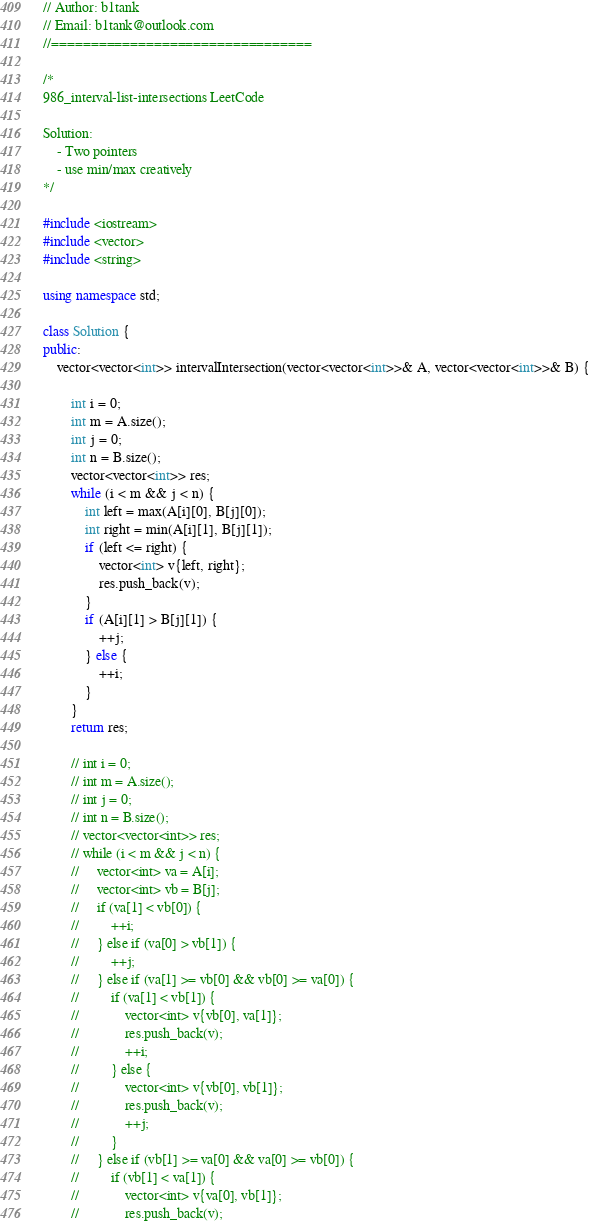<code> <loc_0><loc_0><loc_500><loc_500><_C++_>// Author: b1tank
// Email: b1tank@outlook.com
//=================================

/*
986_interval-list-intersections LeetCode

Solution: 
    - Two pointers
    - use min/max creatively
*/

#include <iostream>
#include <vector>
#include <string>

using namespace std;

class Solution {
public:
    vector<vector<int>> intervalIntersection(vector<vector<int>>& A, vector<vector<int>>& B) {
        
        int i = 0;
        int m = A.size();
        int j = 0;
        int n = B.size();
        vector<vector<int>> res;
        while (i < m && j < n) {
            int left = max(A[i][0], B[j][0]);
            int right = min(A[i][1], B[j][1]);
            if (left <= right) {
                vector<int> v{left, right};
                res.push_back(v);
            }
            if (A[i][1] > B[j][1]) {
                ++j;
            } else {
                ++i;
            }
        }
        return res;
        
        // int i = 0;
        // int m = A.size();
        // int j = 0;
        // int n = B.size();
        // vector<vector<int>> res;
        // while (i < m && j < n) {
        //     vector<int> va = A[i];
        //     vector<int> vb = B[j];
        //     if (va[1] < vb[0]) {
        //         ++i;
        //     } else if (va[0] > vb[1]) {
        //         ++j;
        //     } else if (va[1] >= vb[0] && vb[0] >= va[0]) {
        //         if (va[1] < vb[1]) {
        //             vector<int> v{vb[0], va[1]};
        //             res.push_back(v);
        //             ++i;
        //         } else {
        //             vector<int> v{vb[0], vb[1]};
        //             res.push_back(v);
        //             ++j;
        //         }
        //     } else if (vb[1] >= va[0] && va[0] >= vb[0]) {
        //         if (vb[1] < va[1]) {
        //             vector<int> v{va[0], vb[1]};
        //             res.push_back(v);</code> 